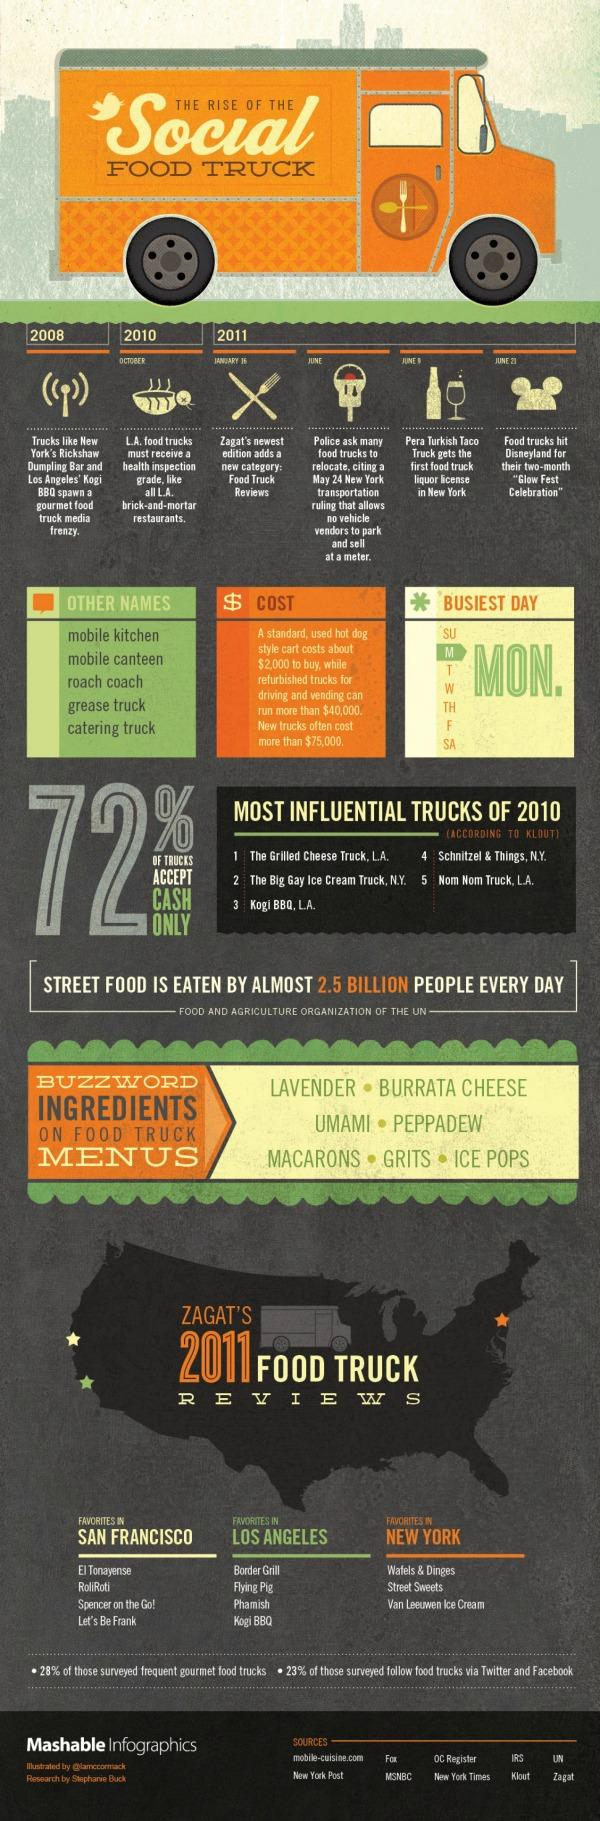Identify some key points in this picture. In 2011, the latest edition of Zagat included a new category called "Food Truck Reviews. The busiest day of the week for food trucks is consistently Monday. 